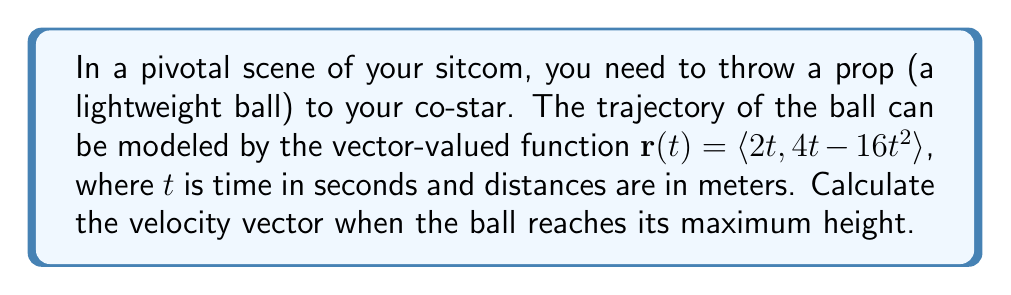Teach me how to tackle this problem. To solve this problem, we'll follow these steps:

1) First, we need to find the velocity vector function. The velocity vector is the derivative of the position vector:

   $\mathbf{v}(t) = \frac{d}{dt}\mathbf{r}(t) = \langle \frac{d}{dt}(2t), \frac{d}{dt}(4t - 16t^2) \rangle = \langle 2, 4 - 32t \rangle$

2) To find when the ball reaches its maximum height, we need to determine when the y-component of the velocity is zero:

   $4 - 32t = 0$
   $-32t = -4$
   $t = \frac{1}{8}$ seconds

3) Now that we know the time at which the ball reaches its maximum height, we can substitute this value into our velocity vector function:

   $\mathbf{v}(\frac{1}{8}) = \langle 2, 4 - 32(\frac{1}{8}) \rangle = \langle 2, 4 - 4 \rangle = \langle 2, 0 \rangle$

Therefore, when the ball reaches its maximum height, its velocity vector is $\langle 2, 0 \rangle$ meters per second.
Answer: $\langle 2, 0 \rangle$ m/s 